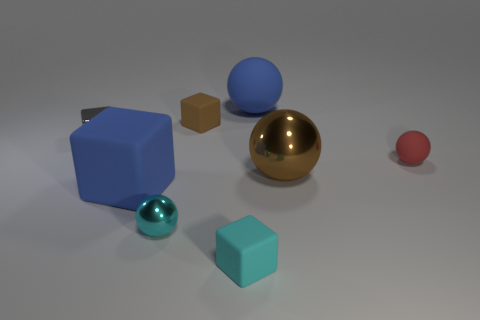Add 5 big gray metal objects. How many big gray metal objects exist? 5 Add 1 big metallic objects. How many objects exist? 9 Subtract all brown balls. How many balls are left? 3 Subtract all blue matte spheres. How many spheres are left? 3 Subtract 0 yellow cylinders. How many objects are left? 8 Subtract 4 cubes. How many cubes are left? 0 Subtract all cyan cubes. Subtract all purple spheres. How many cubes are left? 3 Subtract all gray cylinders. How many brown spheres are left? 1 Subtract all gray metal things. Subtract all small gray metal spheres. How many objects are left? 7 Add 2 cubes. How many cubes are left? 6 